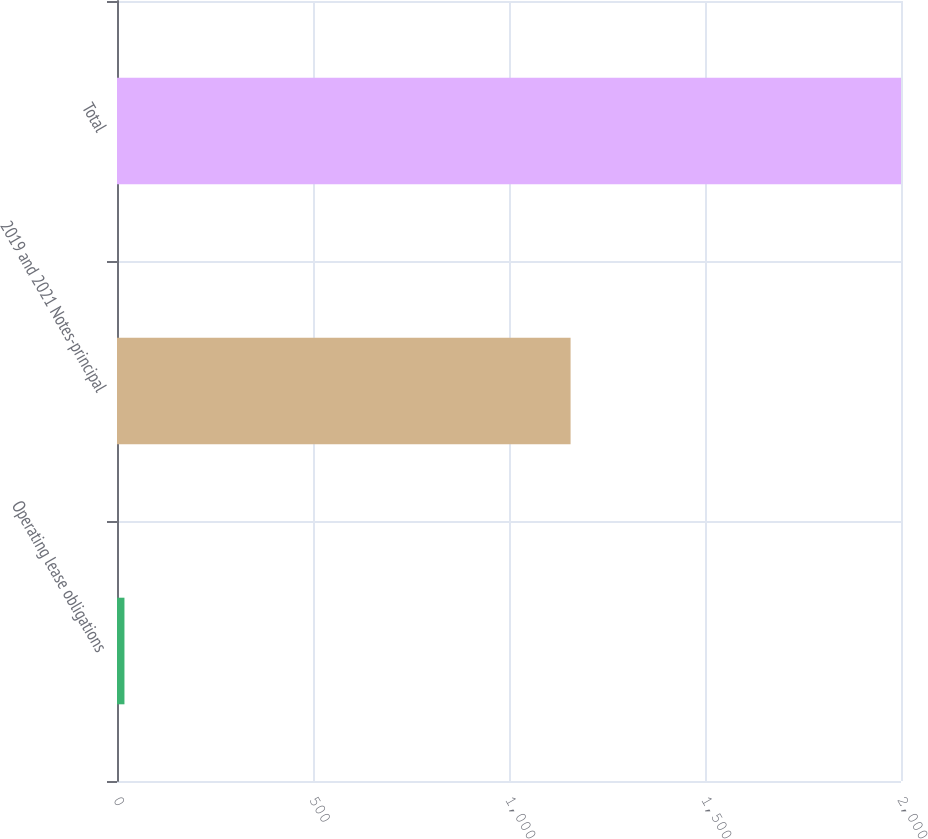<chart> <loc_0><loc_0><loc_500><loc_500><bar_chart><fcel>Operating lease obligations<fcel>2019 and 2021 Notes-principal<fcel>Total<nl><fcel>19<fcel>1157.1<fcel>2000<nl></chart> 